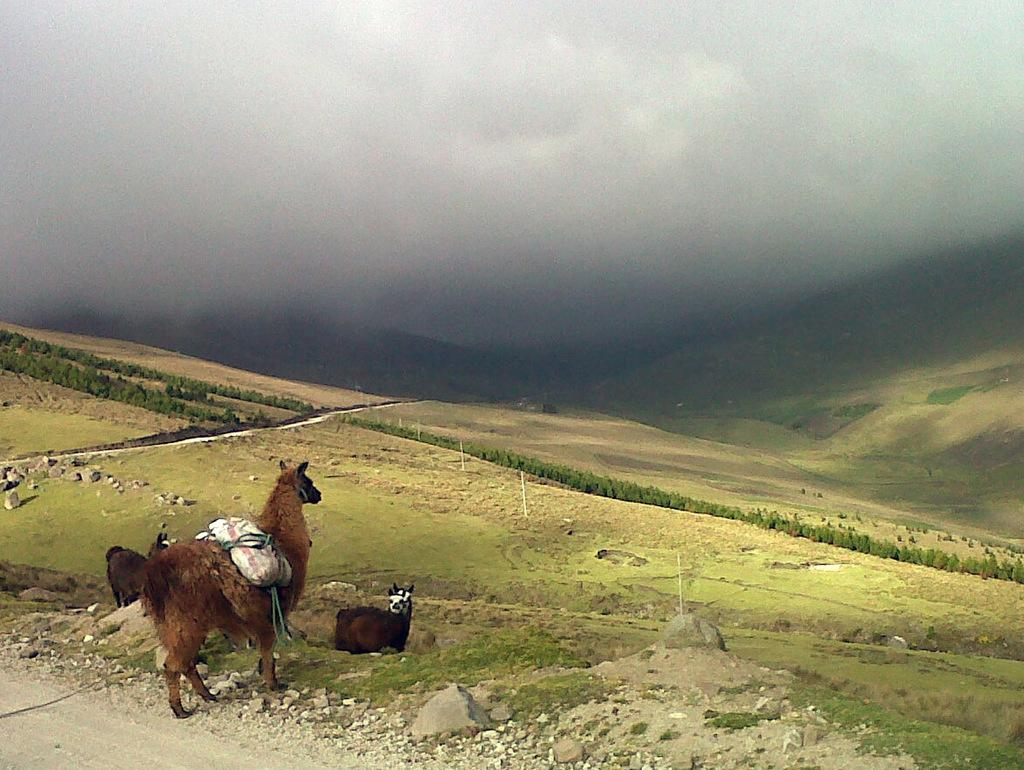What types of living organisms are in the image? There are animals in the image. What type of natural environment is visible in the image? There are trees, grass, and sky visible in the image. Can you describe the object that is on one of the animals? Yes, there is an object on one of the animals, but the specific nature of the object is not clear from the image. What type of pollution can be seen in the image? There is no pollution visible in the image. Is there a stream running through the image? There is no stream visible in the image. What type of tank is present in the image? There is no tank present in the image. 